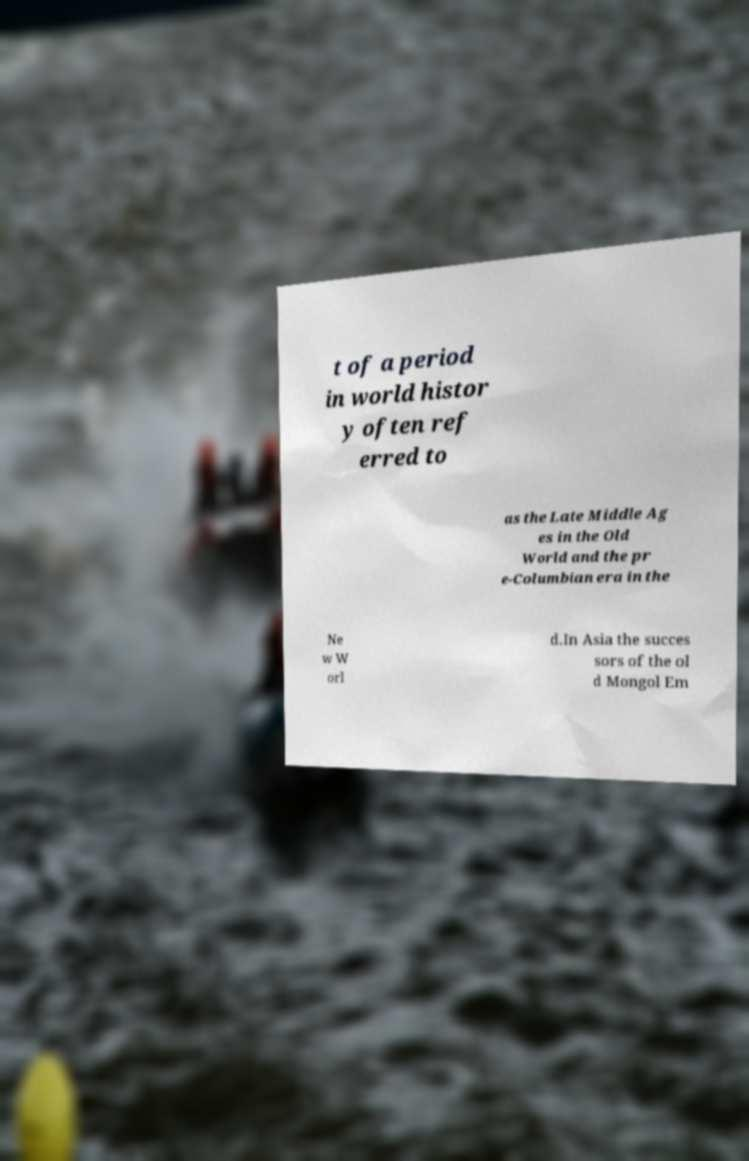I need the written content from this picture converted into text. Can you do that? t of a period in world histor y often ref erred to as the Late Middle Ag es in the Old World and the pr e-Columbian era in the Ne w W orl d.In Asia the succes sors of the ol d Mongol Em 